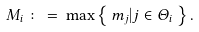<formula> <loc_0><loc_0><loc_500><loc_500>M _ { i } \, \colon = \, \max \left \{ \, m _ { j } | j \in \Theta _ { i } \, \right \} .</formula> 